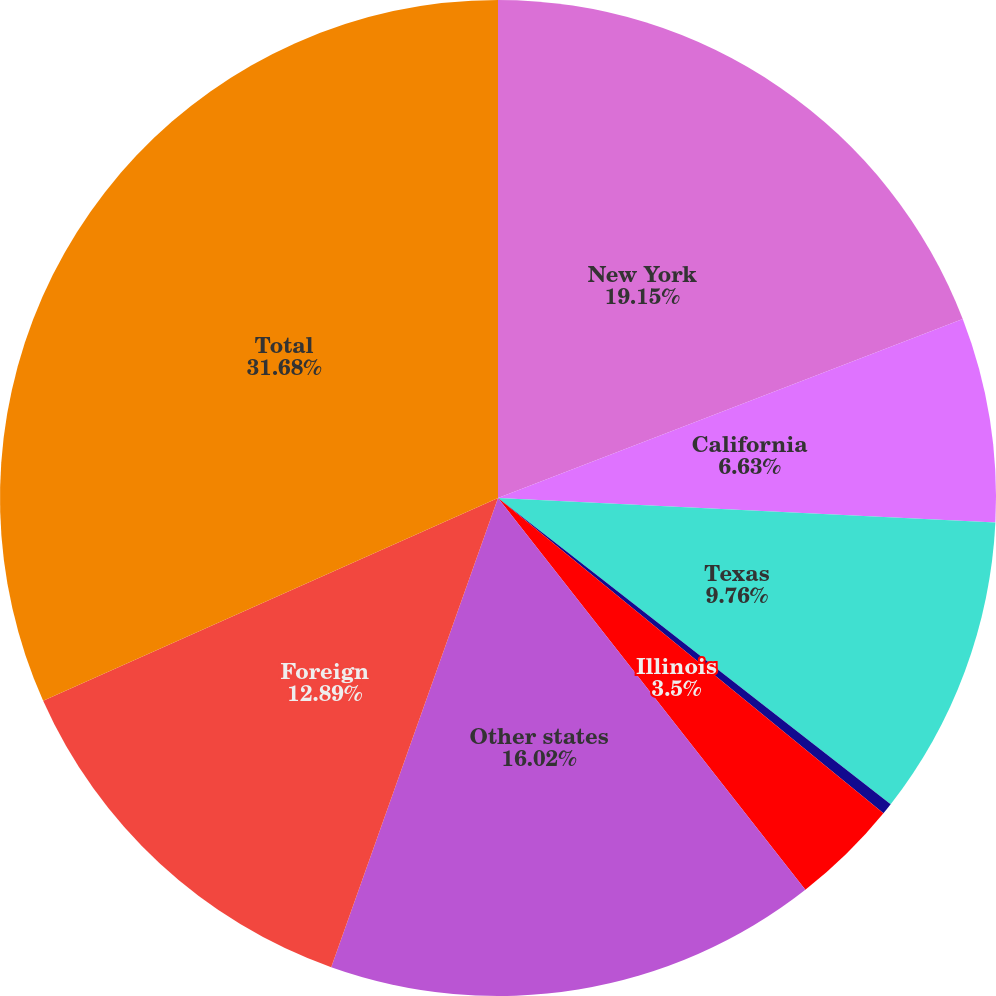Convert chart to OTSL. <chart><loc_0><loc_0><loc_500><loc_500><pie_chart><fcel>New York<fcel>California<fcel>Texas<fcel>Florida<fcel>Illinois<fcel>Other states<fcel>Foreign<fcel>Total<nl><fcel>19.15%<fcel>6.63%<fcel>9.76%<fcel>0.37%<fcel>3.5%<fcel>16.02%<fcel>12.89%<fcel>31.67%<nl></chart> 